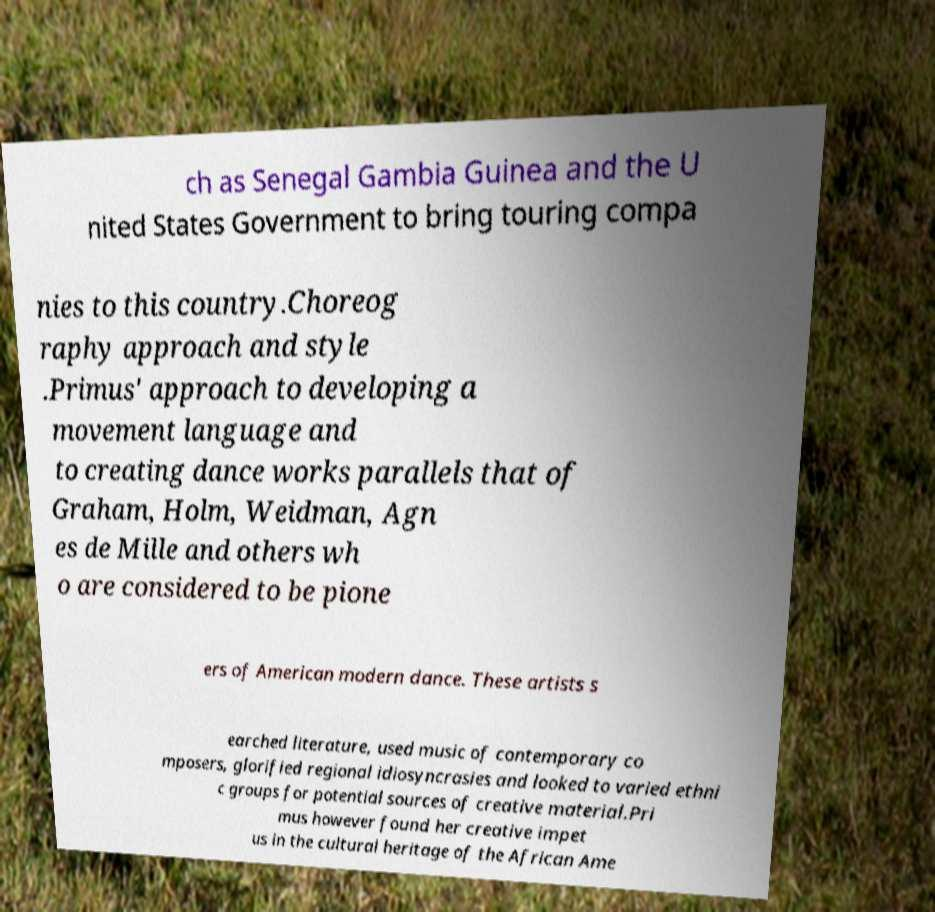Can you accurately transcribe the text from the provided image for me? ch as Senegal Gambia Guinea and the U nited States Government to bring touring compa nies to this country.Choreog raphy approach and style .Primus' approach to developing a movement language and to creating dance works parallels that of Graham, Holm, Weidman, Agn es de Mille and others wh o are considered to be pione ers of American modern dance. These artists s earched literature, used music of contemporary co mposers, glorified regional idiosyncrasies and looked to varied ethni c groups for potential sources of creative material.Pri mus however found her creative impet us in the cultural heritage of the African Ame 